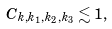Convert formula to latex. <formula><loc_0><loc_0><loc_500><loc_500>C _ { k , k _ { 1 } , k _ { 2 } , k _ { 3 } } \lesssim 1 ,</formula> 